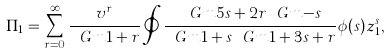<formula> <loc_0><loc_0><loc_500><loc_500>\Pi _ { 1 } = \sum _ { r = 0 } ^ { \infty } \frac { v ^ { r } } { \ G m { 1 + r } } \oint \frac { \ G m { 5 s + 2 r } \ G m { - s } } { \ G m { 1 + s } \ G m { 1 + 3 s + r } } \phi ( s ) z _ { 1 } ^ { s } ,</formula> 